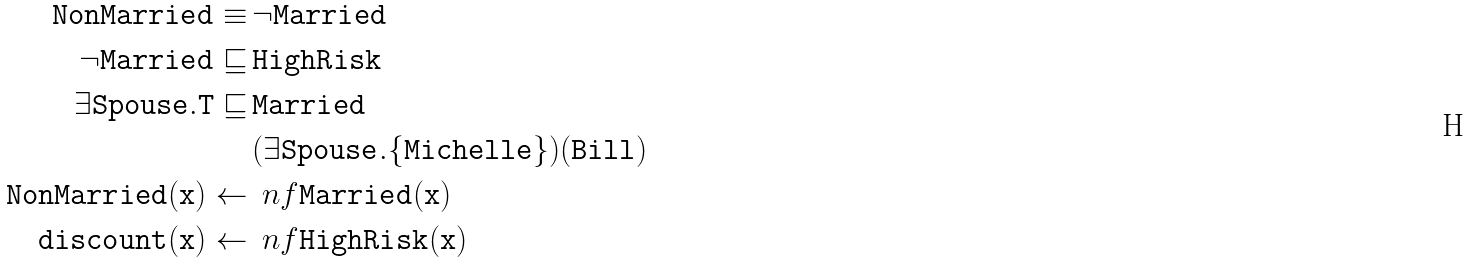<formula> <loc_0><loc_0><loc_500><loc_500>\tt { N o n M a r r i e d } \equiv & \, \tt { \neg M a r r i e d } \\ \neg \tt { M a r r i e d } \sqsubseteq & \, \tt { H i g h R i s k } \\ \exists \tt { S p o u s e } . T \sqsubseteq & \, \tt { M a r r i e d } \\ & \, ( \exists \tt { S p o u s e } . \{ \tt { M i c h e l l e } \} ) ( \tt { B i l l } ) \\ \tt { N o n M a r r i e d } ( \tt { x } ) \leftarrow & \, \ n f \tt { M a r r i e d } ( \tt { x } ) \\ \tt { d i s c o u n t } ( \tt { x } ) \leftarrow & \, \ n f \tt { H i g h R i s k } ( \tt { x } )</formula> 